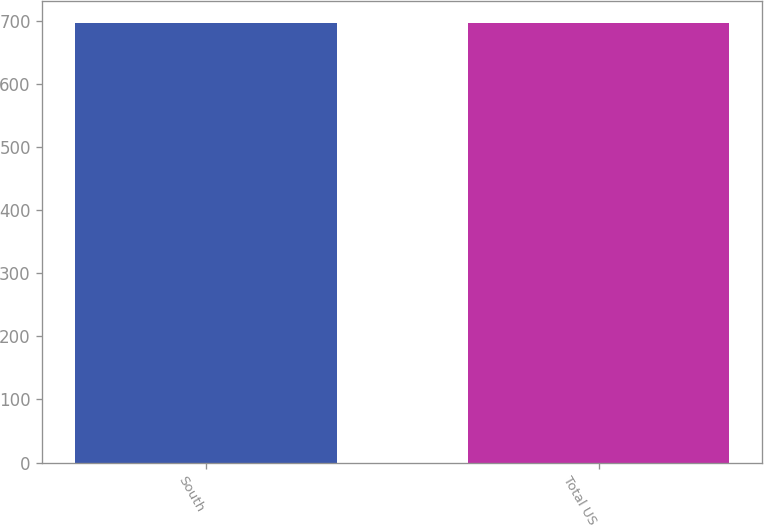Convert chart to OTSL. <chart><loc_0><loc_0><loc_500><loc_500><bar_chart><fcel>South<fcel>Total US<nl><fcel>696<fcel>696.1<nl></chart> 